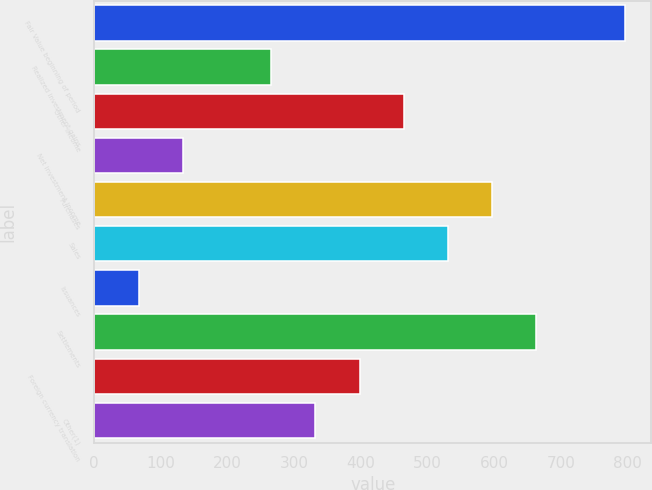<chart> <loc_0><loc_0><loc_500><loc_500><bar_chart><fcel>Fair Value beginning of period<fcel>Realized investment gains<fcel>Other income<fcel>Net investment income<fcel>Purchases<fcel>Sales<fcel>Issuances<fcel>Settlements<fcel>Foreign currency translation<fcel>Other(1)<nl><fcel>795.49<fcel>265.45<fcel>464.2<fcel>132.95<fcel>596.71<fcel>530.45<fcel>66.7<fcel>662.97<fcel>397.95<fcel>331.7<nl></chart> 